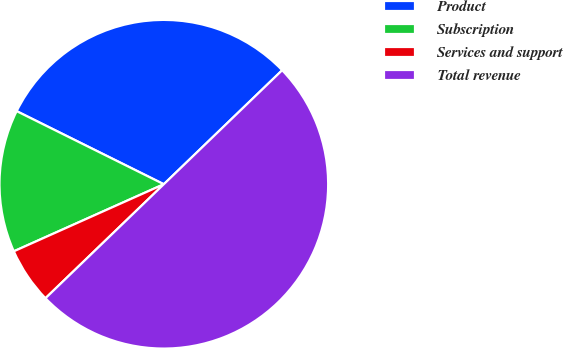Convert chart to OTSL. <chart><loc_0><loc_0><loc_500><loc_500><pie_chart><fcel>Product<fcel>Subscription<fcel>Services and support<fcel>Total revenue<nl><fcel>30.46%<fcel>14.03%<fcel>5.51%<fcel>50.0%<nl></chart> 